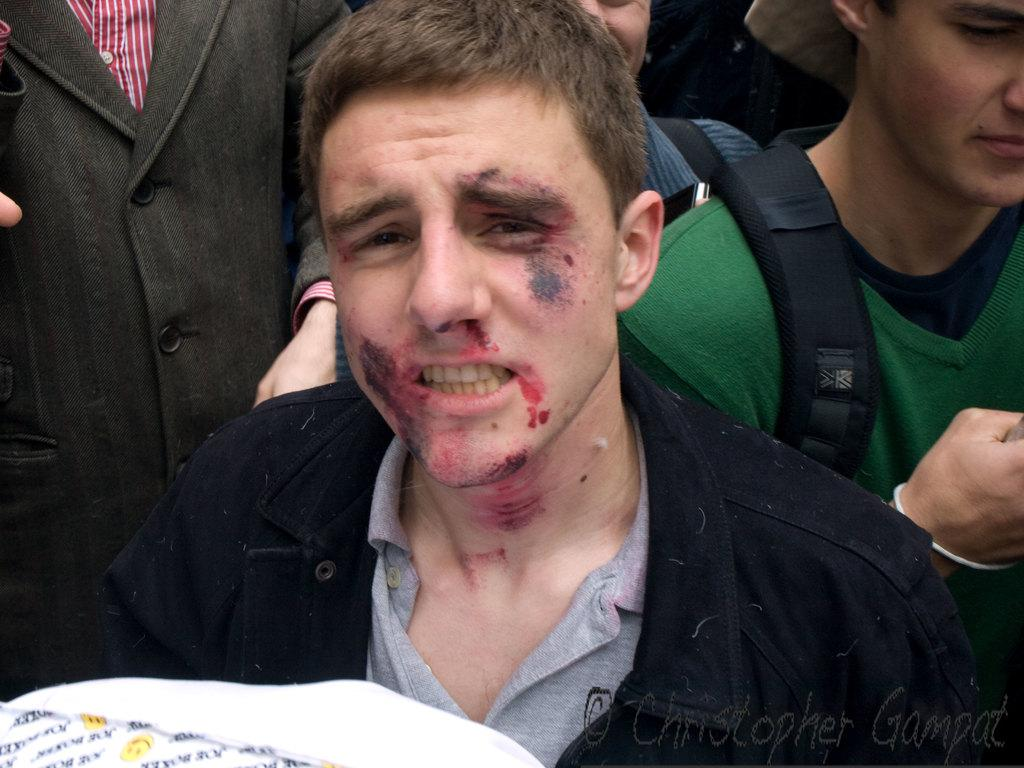How many people are in the image? There are people in the image, but the exact number is not specified. Can you describe the object in the bottom left corner of the image? Unfortunately, the facts provided do not give any details about the object in the bottom left corner of the image. How do the people in the image sort their accounts? There is no information provided about the people sorting their accounts in the image. 